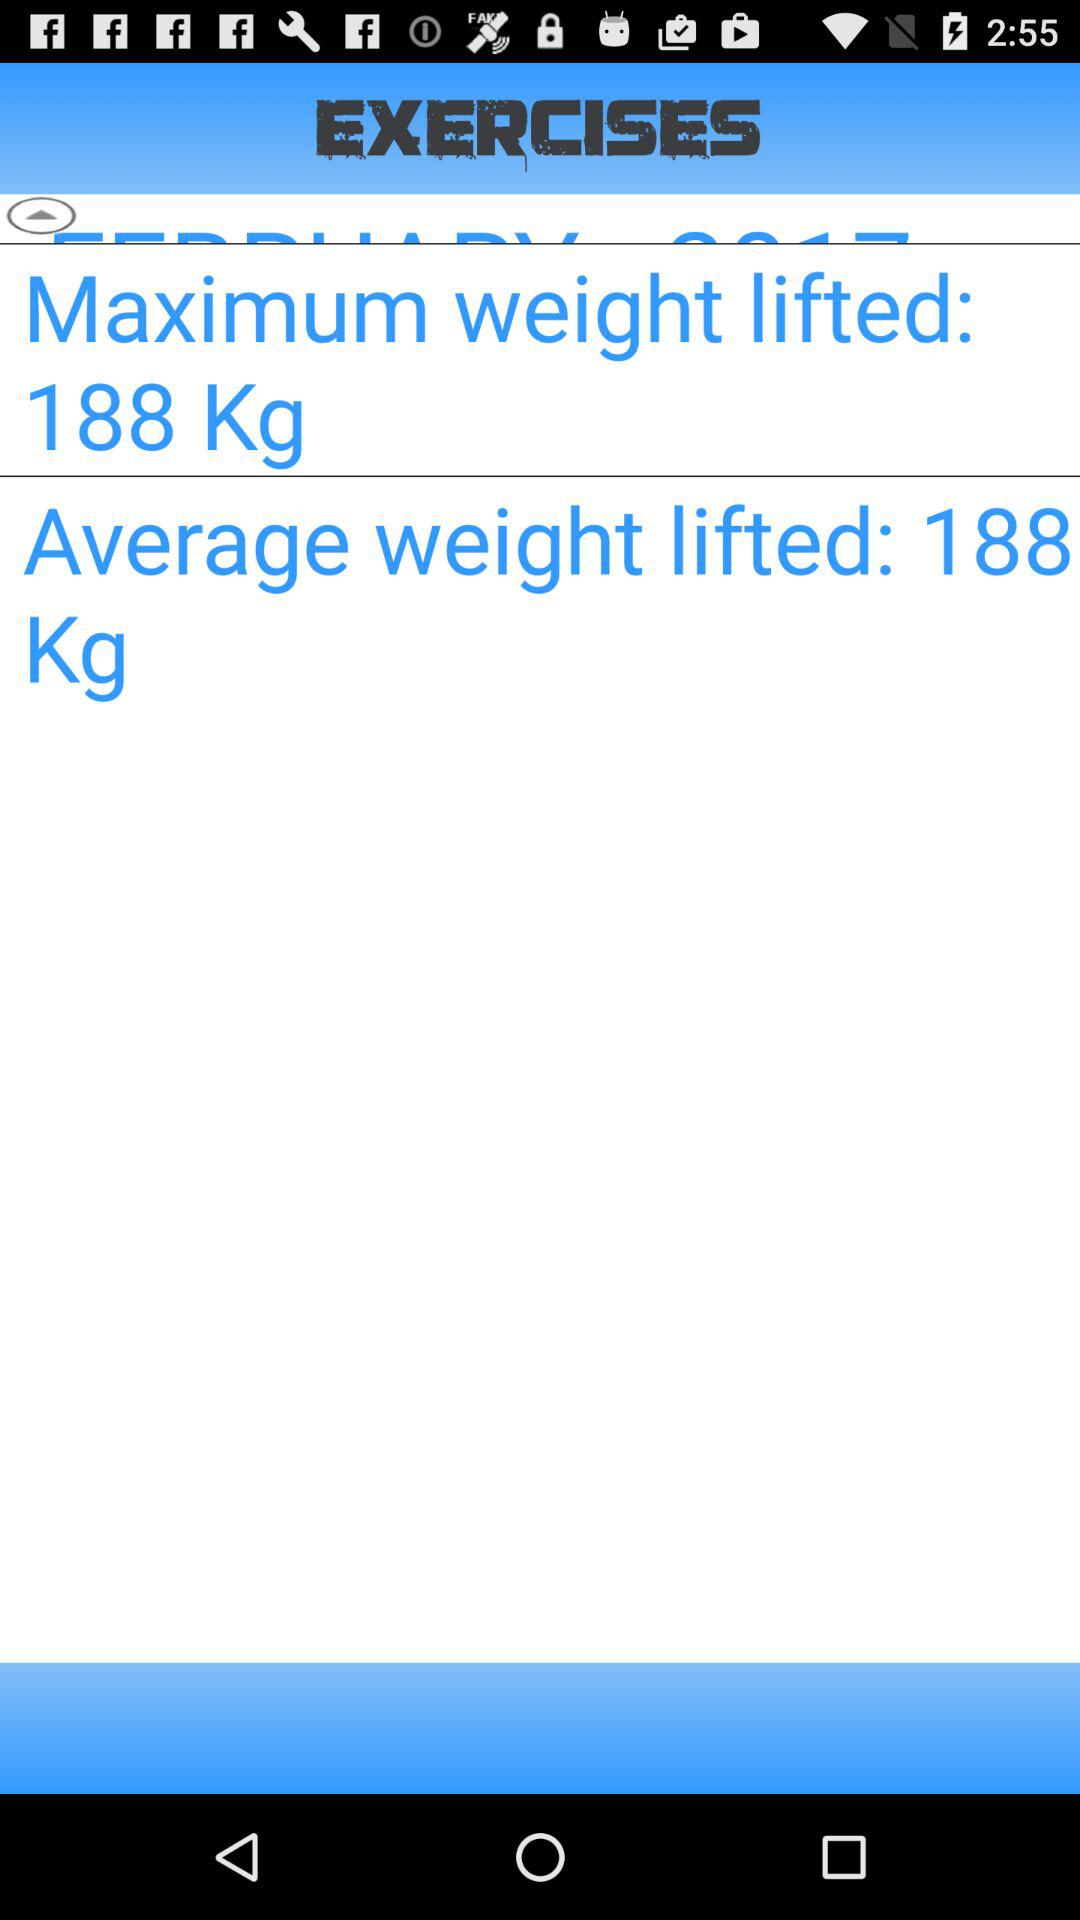What is the maximum weight lifted? The maximum weight lifted is 188 kg. 